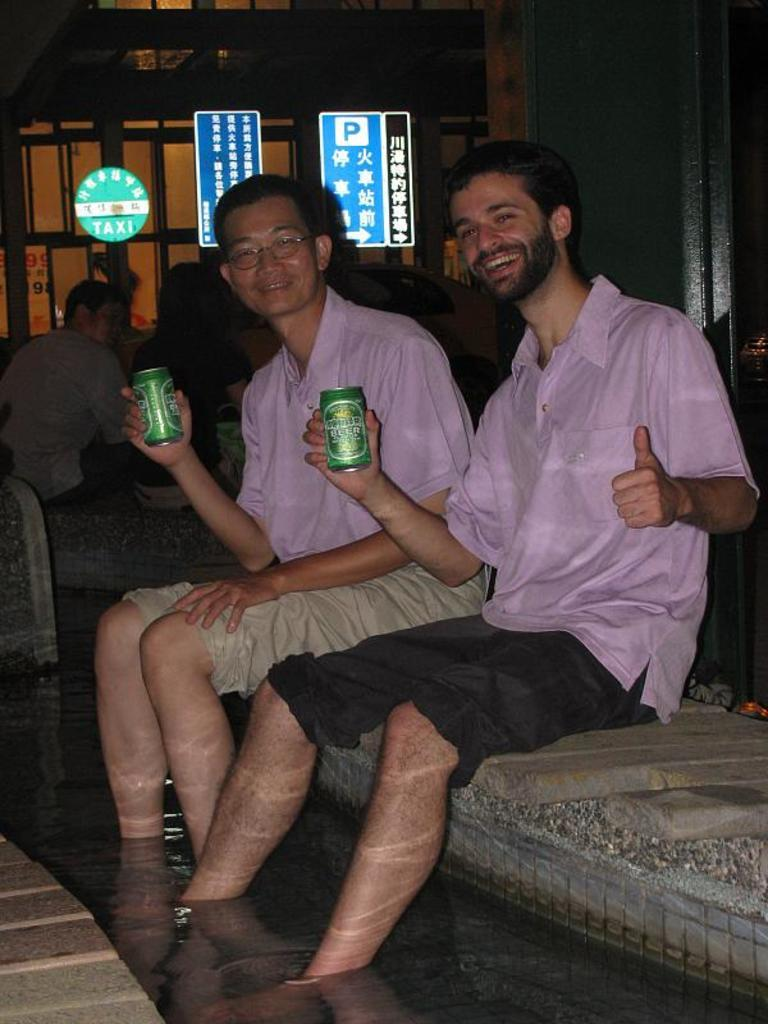What is happening in the image? There is a group of people in the image. Where are the people sitting? The people are sitting on a sofa. What are the people holding? The people are holding a tin. What type of bridge can be seen in the image? There is no bridge present in the image; it features a group of people sitting on a sofa and holding a tin. 